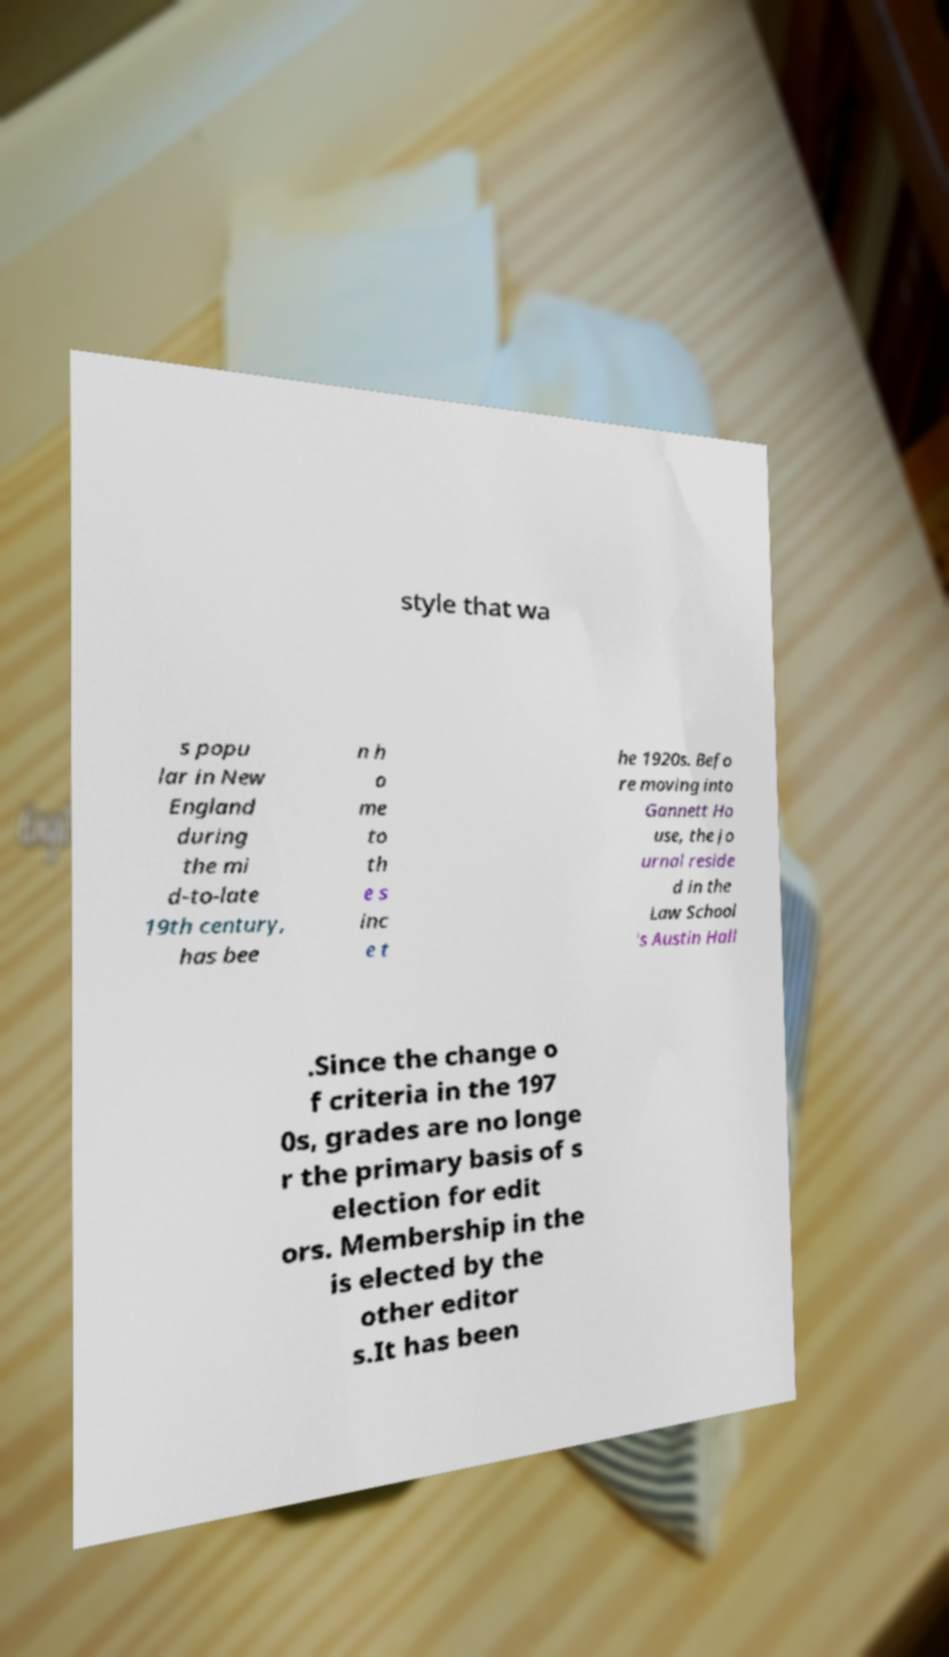Please read and relay the text visible in this image. What does it say? style that wa s popu lar in New England during the mi d-to-late 19th century, has bee n h o me to th e s inc e t he 1920s. Befo re moving into Gannett Ho use, the jo urnal reside d in the Law School 's Austin Hall .Since the change o f criteria in the 197 0s, grades are no longe r the primary basis of s election for edit ors. Membership in the is elected by the other editor s.It has been 